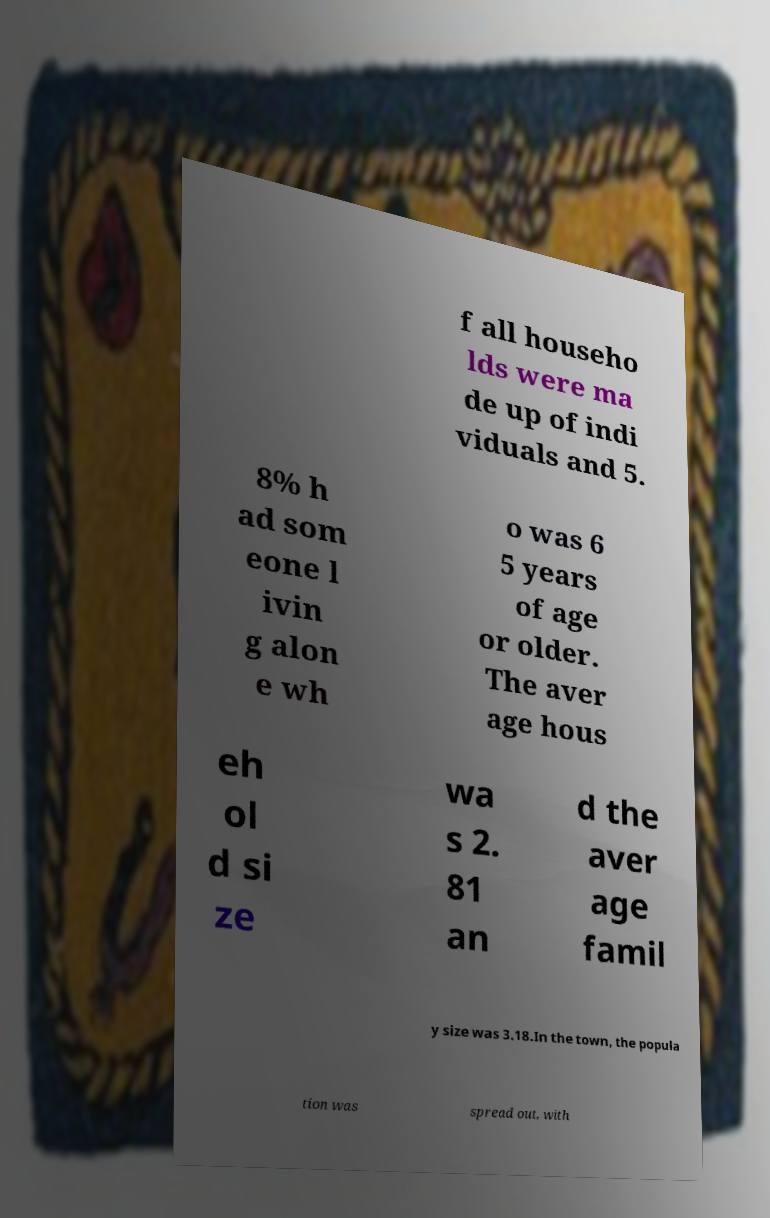Please read and relay the text visible in this image. What does it say? f all househo lds were ma de up of indi viduals and 5. 8% h ad som eone l ivin g alon e wh o was 6 5 years of age or older. The aver age hous eh ol d si ze wa s 2. 81 an d the aver age famil y size was 3.18.In the town, the popula tion was spread out, with 